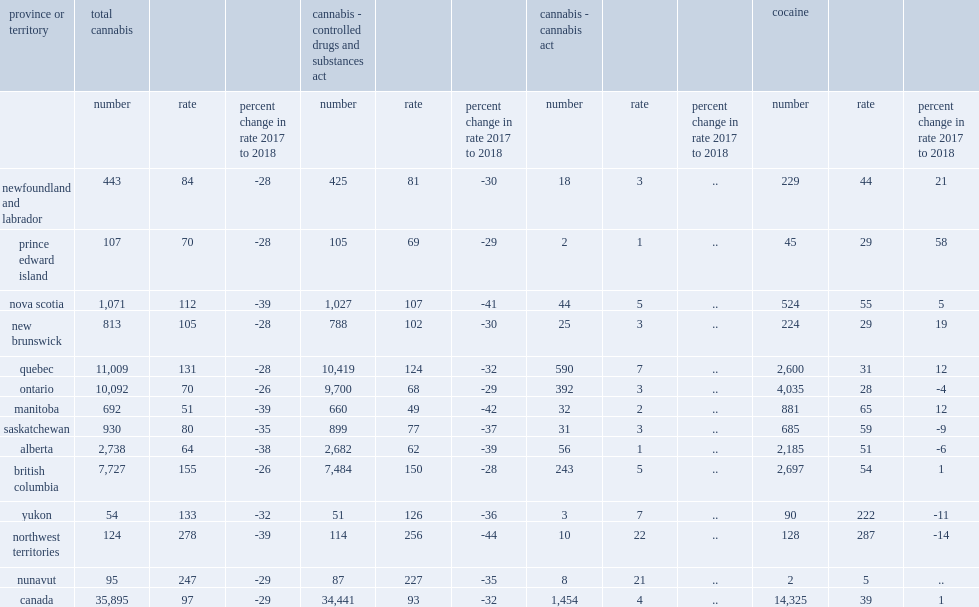What was the lowest police-reported rates for total, combined cannabis offences were recorded in manitoba? 51.0. What was the lowest police-reported rates for total, combined cannabis offences were recorded in alberta? 64.0. What was the lowest police-reported rates for total, combined cannabis offences were recorded in ontario? 70.0. What was the lowest police-reported rates for total, combined cannabis offences were recorded in prince edward island? 70.0. 